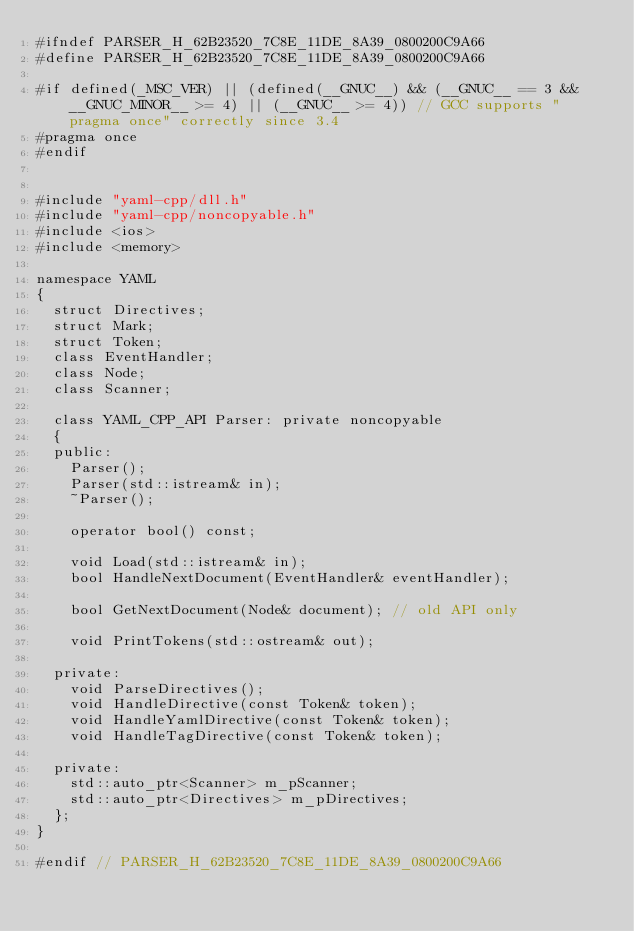Convert code to text. <code><loc_0><loc_0><loc_500><loc_500><_C_>#ifndef PARSER_H_62B23520_7C8E_11DE_8A39_0800200C9A66
#define PARSER_H_62B23520_7C8E_11DE_8A39_0800200C9A66

#if defined(_MSC_VER) || (defined(__GNUC__) && (__GNUC__ == 3 && __GNUC_MINOR__ >= 4) || (__GNUC__ >= 4)) // GCC supports "pragma once" correctly since 3.4
#pragma once
#endif


#include "yaml-cpp/dll.h"
#include "yaml-cpp/noncopyable.h"
#include <ios>
#include <memory>

namespace YAML
{
	struct Directives;
	struct Mark;
	struct Token;
	class EventHandler;
	class Node;
	class Scanner;

	class YAML_CPP_API Parser: private noncopyable
	{
	public:
		Parser();
		Parser(std::istream& in);
		~Parser();

		operator bool() const;

		void Load(std::istream& in);
		bool HandleNextDocument(EventHandler& eventHandler);
		
		bool GetNextDocument(Node& document); // old API only
		
		void PrintTokens(std::ostream& out);

	private:
		void ParseDirectives();
		void HandleDirective(const Token& token);
		void HandleYamlDirective(const Token& token);
		void HandleTagDirective(const Token& token);
		
	private:
		std::auto_ptr<Scanner> m_pScanner;
		std::auto_ptr<Directives> m_pDirectives;
	};
}

#endif // PARSER_H_62B23520_7C8E_11DE_8A39_0800200C9A66
</code> 